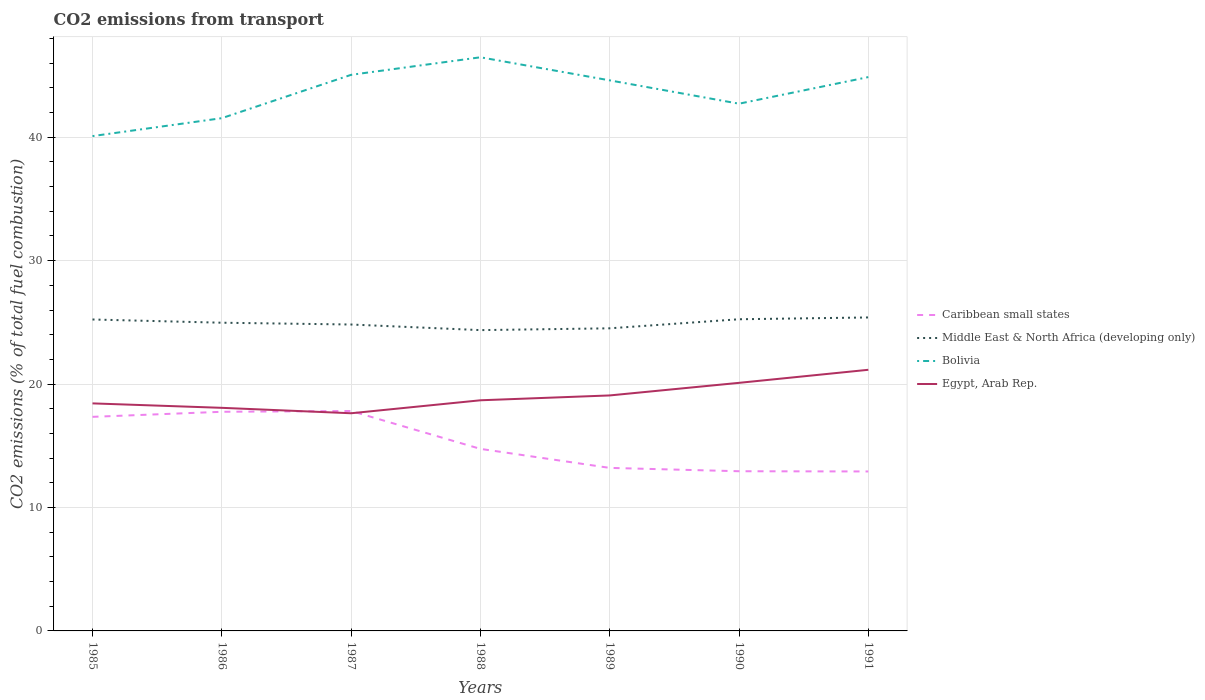How many different coloured lines are there?
Provide a short and direct response. 4. Is the number of lines equal to the number of legend labels?
Keep it short and to the point. Yes. Across all years, what is the maximum total CO2 emitted in Egypt, Arab Rep.?
Offer a very short reply. 17.64. What is the total total CO2 emitted in Caribbean small states in the graph?
Provide a succinct answer. 0.29. What is the difference between the highest and the second highest total CO2 emitted in Egypt, Arab Rep.?
Keep it short and to the point. 3.52. Is the total CO2 emitted in Middle East & North Africa (developing only) strictly greater than the total CO2 emitted in Bolivia over the years?
Provide a succinct answer. Yes. Does the graph contain any zero values?
Ensure brevity in your answer.  No. How many legend labels are there?
Your response must be concise. 4. What is the title of the graph?
Make the answer very short. CO2 emissions from transport. What is the label or title of the Y-axis?
Keep it short and to the point. CO2 emissions (% of total fuel combustion). What is the CO2 emissions (% of total fuel combustion) in Caribbean small states in 1985?
Give a very brief answer. 17.35. What is the CO2 emissions (% of total fuel combustion) in Middle East & North Africa (developing only) in 1985?
Offer a very short reply. 25.23. What is the CO2 emissions (% of total fuel combustion) in Bolivia in 1985?
Ensure brevity in your answer.  40.09. What is the CO2 emissions (% of total fuel combustion) of Egypt, Arab Rep. in 1985?
Your answer should be compact. 18.44. What is the CO2 emissions (% of total fuel combustion) in Caribbean small states in 1986?
Your answer should be compact. 17.76. What is the CO2 emissions (% of total fuel combustion) in Middle East & North Africa (developing only) in 1986?
Your response must be concise. 24.97. What is the CO2 emissions (% of total fuel combustion) of Bolivia in 1986?
Provide a succinct answer. 41.55. What is the CO2 emissions (% of total fuel combustion) of Egypt, Arab Rep. in 1986?
Your answer should be very brief. 18.08. What is the CO2 emissions (% of total fuel combustion) in Caribbean small states in 1987?
Ensure brevity in your answer.  17.82. What is the CO2 emissions (% of total fuel combustion) of Middle East & North Africa (developing only) in 1987?
Make the answer very short. 24.83. What is the CO2 emissions (% of total fuel combustion) in Bolivia in 1987?
Your answer should be very brief. 45.06. What is the CO2 emissions (% of total fuel combustion) of Egypt, Arab Rep. in 1987?
Your answer should be compact. 17.64. What is the CO2 emissions (% of total fuel combustion) in Caribbean small states in 1988?
Ensure brevity in your answer.  14.75. What is the CO2 emissions (% of total fuel combustion) of Middle East & North Africa (developing only) in 1988?
Provide a short and direct response. 24.37. What is the CO2 emissions (% of total fuel combustion) in Bolivia in 1988?
Your response must be concise. 46.48. What is the CO2 emissions (% of total fuel combustion) of Egypt, Arab Rep. in 1988?
Provide a short and direct response. 18.69. What is the CO2 emissions (% of total fuel combustion) in Caribbean small states in 1989?
Make the answer very short. 13.21. What is the CO2 emissions (% of total fuel combustion) of Middle East & North Africa (developing only) in 1989?
Provide a short and direct response. 24.52. What is the CO2 emissions (% of total fuel combustion) in Bolivia in 1989?
Provide a succinct answer. 44.61. What is the CO2 emissions (% of total fuel combustion) of Egypt, Arab Rep. in 1989?
Offer a terse response. 19.08. What is the CO2 emissions (% of total fuel combustion) of Caribbean small states in 1990?
Your answer should be compact. 12.94. What is the CO2 emissions (% of total fuel combustion) of Middle East & North Africa (developing only) in 1990?
Give a very brief answer. 25.25. What is the CO2 emissions (% of total fuel combustion) in Bolivia in 1990?
Provide a short and direct response. 42.72. What is the CO2 emissions (% of total fuel combustion) of Egypt, Arab Rep. in 1990?
Ensure brevity in your answer.  20.1. What is the CO2 emissions (% of total fuel combustion) of Caribbean small states in 1991?
Your answer should be very brief. 12.92. What is the CO2 emissions (% of total fuel combustion) of Middle East & North Africa (developing only) in 1991?
Offer a very short reply. 25.4. What is the CO2 emissions (% of total fuel combustion) in Bolivia in 1991?
Your response must be concise. 44.87. What is the CO2 emissions (% of total fuel combustion) of Egypt, Arab Rep. in 1991?
Offer a very short reply. 21.16. Across all years, what is the maximum CO2 emissions (% of total fuel combustion) of Caribbean small states?
Make the answer very short. 17.82. Across all years, what is the maximum CO2 emissions (% of total fuel combustion) of Middle East & North Africa (developing only)?
Make the answer very short. 25.4. Across all years, what is the maximum CO2 emissions (% of total fuel combustion) in Bolivia?
Provide a short and direct response. 46.48. Across all years, what is the maximum CO2 emissions (% of total fuel combustion) in Egypt, Arab Rep.?
Keep it short and to the point. 21.16. Across all years, what is the minimum CO2 emissions (% of total fuel combustion) of Caribbean small states?
Give a very brief answer. 12.92. Across all years, what is the minimum CO2 emissions (% of total fuel combustion) of Middle East & North Africa (developing only)?
Offer a very short reply. 24.37. Across all years, what is the minimum CO2 emissions (% of total fuel combustion) in Bolivia?
Provide a short and direct response. 40.09. Across all years, what is the minimum CO2 emissions (% of total fuel combustion) in Egypt, Arab Rep.?
Keep it short and to the point. 17.64. What is the total CO2 emissions (% of total fuel combustion) of Caribbean small states in the graph?
Provide a succinct answer. 106.74. What is the total CO2 emissions (% of total fuel combustion) of Middle East & North Africa (developing only) in the graph?
Offer a terse response. 174.58. What is the total CO2 emissions (% of total fuel combustion) in Bolivia in the graph?
Offer a very short reply. 305.38. What is the total CO2 emissions (% of total fuel combustion) in Egypt, Arab Rep. in the graph?
Your answer should be compact. 133.18. What is the difference between the CO2 emissions (% of total fuel combustion) in Caribbean small states in 1985 and that in 1986?
Provide a short and direct response. -0.41. What is the difference between the CO2 emissions (% of total fuel combustion) in Middle East & North Africa (developing only) in 1985 and that in 1986?
Keep it short and to the point. 0.26. What is the difference between the CO2 emissions (% of total fuel combustion) in Bolivia in 1985 and that in 1986?
Ensure brevity in your answer.  -1.45. What is the difference between the CO2 emissions (% of total fuel combustion) of Egypt, Arab Rep. in 1985 and that in 1986?
Give a very brief answer. 0.36. What is the difference between the CO2 emissions (% of total fuel combustion) in Caribbean small states in 1985 and that in 1987?
Provide a short and direct response. -0.47. What is the difference between the CO2 emissions (% of total fuel combustion) in Middle East & North Africa (developing only) in 1985 and that in 1987?
Give a very brief answer. 0.41. What is the difference between the CO2 emissions (% of total fuel combustion) in Bolivia in 1985 and that in 1987?
Provide a succinct answer. -4.96. What is the difference between the CO2 emissions (% of total fuel combustion) in Egypt, Arab Rep. in 1985 and that in 1987?
Provide a succinct answer. 0.8. What is the difference between the CO2 emissions (% of total fuel combustion) of Caribbean small states in 1985 and that in 1988?
Your answer should be very brief. 2.6. What is the difference between the CO2 emissions (% of total fuel combustion) of Middle East & North Africa (developing only) in 1985 and that in 1988?
Your answer should be very brief. 0.86. What is the difference between the CO2 emissions (% of total fuel combustion) in Bolivia in 1985 and that in 1988?
Give a very brief answer. -6.39. What is the difference between the CO2 emissions (% of total fuel combustion) of Egypt, Arab Rep. in 1985 and that in 1988?
Give a very brief answer. -0.25. What is the difference between the CO2 emissions (% of total fuel combustion) in Caribbean small states in 1985 and that in 1989?
Your answer should be very brief. 4.14. What is the difference between the CO2 emissions (% of total fuel combustion) in Middle East & North Africa (developing only) in 1985 and that in 1989?
Your answer should be compact. 0.71. What is the difference between the CO2 emissions (% of total fuel combustion) of Bolivia in 1985 and that in 1989?
Offer a very short reply. -4.52. What is the difference between the CO2 emissions (% of total fuel combustion) of Egypt, Arab Rep. in 1985 and that in 1989?
Keep it short and to the point. -0.64. What is the difference between the CO2 emissions (% of total fuel combustion) in Caribbean small states in 1985 and that in 1990?
Keep it short and to the point. 4.41. What is the difference between the CO2 emissions (% of total fuel combustion) of Middle East & North Africa (developing only) in 1985 and that in 1990?
Keep it short and to the point. -0.02. What is the difference between the CO2 emissions (% of total fuel combustion) of Bolivia in 1985 and that in 1990?
Offer a very short reply. -2.63. What is the difference between the CO2 emissions (% of total fuel combustion) in Egypt, Arab Rep. in 1985 and that in 1990?
Your answer should be compact. -1.66. What is the difference between the CO2 emissions (% of total fuel combustion) of Caribbean small states in 1985 and that in 1991?
Make the answer very short. 4.43. What is the difference between the CO2 emissions (% of total fuel combustion) of Middle East & North Africa (developing only) in 1985 and that in 1991?
Your response must be concise. -0.17. What is the difference between the CO2 emissions (% of total fuel combustion) of Bolivia in 1985 and that in 1991?
Your answer should be very brief. -4.78. What is the difference between the CO2 emissions (% of total fuel combustion) of Egypt, Arab Rep. in 1985 and that in 1991?
Provide a short and direct response. -2.72. What is the difference between the CO2 emissions (% of total fuel combustion) in Caribbean small states in 1986 and that in 1987?
Make the answer very short. -0.06. What is the difference between the CO2 emissions (% of total fuel combustion) of Middle East & North Africa (developing only) in 1986 and that in 1987?
Your response must be concise. 0.15. What is the difference between the CO2 emissions (% of total fuel combustion) in Bolivia in 1986 and that in 1987?
Keep it short and to the point. -3.51. What is the difference between the CO2 emissions (% of total fuel combustion) of Egypt, Arab Rep. in 1986 and that in 1987?
Offer a very short reply. 0.44. What is the difference between the CO2 emissions (% of total fuel combustion) in Caribbean small states in 1986 and that in 1988?
Provide a succinct answer. 3.01. What is the difference between the CO2 emissions (% of total fuel combustion) of Middle East & North Africa (developing only) in 1986 and that in 1988?
Ensure brevity in your answer.  0.6. What is the difference between the CO2 emissions (% of total fuel combustion) of Bolivia in 1986 and that in 1988?
Your response must be concise. -4.93. What is the difference between the CO2 emissions (% of total fuel combustion) in Egypt, Arab Rep. in 1986 and that in 1988?
Your answer should be compact. -0.61. What is the difference between the CO2 emissions (% of total fuel combustion) in Caribbean small states in 1986 and that in 1989?
Make the answer very short. 4.55. What is the difference between the CO2 emissions (% of total fuel combustion) of Middle East & North Africa (developing only) in 1986 and that in 1989?
Make the answer very short. 0.45. What is the difference between the CO2 emissions (% of total fuel combustion) in Bolivia in 1986 and that in 1989?
Provide a short and direct response. -3.06. What is the difference between the CO2 emissions (% of total fuel combustion) of Egypt, Arab Rep. in 1986 and that in 1989?
Ensure brevity in your answer.  -1. What is the difference between the CO2 emissions (% of total fuel combustion) in Caribbean small states in 1986 and that in 1990?
Give a very brief answer. 4.82. What is the difference between the CO2 emissions (% of total fuel combustion) in Middle East & North Africa (developing only) in 1986 and that in 1990?
Your answer should be compact. -0.28. What is the difference between the CO2 emissions (% of total fuel combustion) of Bolivia in 1986 and that in 1990?
Provide a succinct answer. -1.17. What is the difference between the CO2 emissions (% of total fuel combustion) in Egypt, Arab Rep. in 1986 and that in 1990?
Your response must be concise. -2.02. What is the difference between the CO2 emissions (% of total fuel combustion) in Caribbean small states in 1986 and that in 1991?
Provide a succinct answer. 4.84. What is the difference between the CO2 emissions (% of total fuel combustion) of Middle East & North Africa (developing only) in 1986 and that in 1991?
Your answer should be very brief. -0.43. What is the difference between the CO2 emissions (% of total fuel combustion) of Bolivia in 1986 and that in 1991?
Provide a succinct answer. -3.33. What is the difference between the CO2 emissions (% of total fuel combustion) in Egypt, Arab Rep. in 1986 and that in 1991?
Offer a very short reply. -3.08. What is the difference between the CO2 emissions (% of total fuel combustion) of Caribbean small states in 1987 and that in 1988?
Give a very brief answer. 3.07. What is the difference between the CO2 emissions (% of total fuel combustion) of Middle East & North Africa (developing only) in 1987 and that in 1988?
Your answer should be very brief. 0.45. What is the difference between the CO2 emissions (% of total fuel combustion) of Bolivia in 1987 and that in 1988?
Your answer should be very brief. -1.42. What is the difference between the CO2 emissions (% of total fuel combustion) in Egypt, Arab Rep. in 1987 and that in 1988?
Provide a succinct answer. -1.05. What is the difference between the CO2 emissions (% of total fuel combustion) of Caribbean small states in 1987 and that in 1989?
Provide a short and direct response. 4.61. What is the difference between the CO2 emissions (% of total fuel combustion) of Middle East & North Africa (developing only) in 1987 and that in 1989?
Offer a very short reply. 0.31. What is the difference between the CO2 emissions (% of total fuel combustion) in Bolivia in 1987 and that in 1989?
Offer a terse response. 0.45. What is the difference between the CO2 emissions (% of total fuel combustion) in Egypt, Arab Rep. in 1987 and that in 1989?
Offer a very short reply. -1.44. What is the difference between the CO2 emissions (% of total fuel combustion) in Caribbean small states in 1987 and that in 1990?
Offer a terse response. 4.88. What is the difference between the CO2 emissions (% of total fuel combustion) in Middle East & North Africa (developing only) in 1987 and that in 1990?
Provide a succinct answer. -0.43. What is the difference between the CO2 emissions (% of total fuel combustion) of Bolivia in 1987 and that in 1990?
Offer a terse response. 2.34. What is the difference between the CO2 emissions (% of total fuel combustion) of Egypt, Arab Rep. in 1987 and that in 1990?
Offer a very short reply. -2.46. What is the difference between the CO2 emissions (% of total fuel combustion) in Caribbean small states in 1987 and that in 1991?
Provide a succinct answer. 4.9. What is the difference between the CO2 emissions (% of total fuel combustion) of Middle East & North Africa (developing only) in 1987 and that in 1991?
Keep it short and to the point. -0.57. What is the difference between the CO2 emissions (% of total fuel combustion) of Bolivia in 1987 and that in 1991?
Your answer should be compact. 0.18. What is the difference between the CO2 emissions (% of total fuel combustion) in Egypt, Arab Rep. in 1987 and that in 1991?
Provide a short and direct response. -3.52. What is the difference between the CO2 emissions (% of total fuel combustion) in Caribbean small states in 1988 and that in 1989?
Your answer should be very brief. 1.54. What is the difference between the CO2 emissions (% of total fuel combustion) in Middle East & North Africa (developing only) in 1988 and that in 1989?
Provide a succinct answer. -0.15. What is the difference between the CO2 emissions (% of total fuel combustion) in Bolivia in 1988 and that in 1989?
Offer a terse response. 1.87. What is the difference between the CO2 emissions (% of total fuel combustion) of Egypt, Arab Rep. in 1988 and that in 1989?
Ensure brevity in your answer.  -0.39. What is the difference between the CO2 emissions (% of total fuel combustion) in Caribbean small states in 1988 and that in 1990?
Offer a terse response. 1.81. What is the difference between the CO2 emissions (% of total fuel combustion) of Middle East & North Africa (developing only) in 1988 and that in 1990?
Offer a very short reply. -0.88. What is the difference between the CO2 emissions (% of total fuel combustion) of Bolivia in 1988 and that in 1990?
Keep it short and to the point. 3.76. What is the difference between the CO2 emissions (% of total fuel combustion) in Egypt, Arab Rep. in 1988 and that in 1990?
Your answer should be compact. -1.41. What is the difference between the CO2 emissions (% of total fuel combustion) of Caribbean small states in 1988 and that in 1991?
Your response must be concise. 1.83. What is the difference between the CO2 emissions (% of total fuel combustion) of Middle East & North Africa (developing only) in 1988 and that in 1991?
Provide a short and direct response. -1.03. What is the difference between the CO2 emissions (% of total fuel combustion) of Bolivia in 1988 and that in 1991?
Give a very brief answer. 1.6. What is the difference between the CO2 emissions (% of total fuel combustion) in Egypt, Arab Rep. in 1988 and that in 1991?
Ensure brevity in your answer.  -2.47. What is the difference between the CO2 emissions (% of total fuel combustion) of Caribbean small states in 1989 and that in 1990?
Your answer should be compact. 0.27. What is the difference between the CO2 emissions (% of total fuel combustion) in Middle East & North Africa (developing only) in 1989 and that in 1990?
Give a very brief answer. -0.73. What is the difference between the CO2 emissions (% of total fuel combustion) of Bolivia in 1989 and that in 1990?
Give a very brief answer. 1.89. What is the difference between the CO2 emissions (% of total fuel combustion) in Egypt, Arab Rep. in 1989 and that in 1990?
Make the answer very short. -1.02. What is the difference between the CO2 emissions (% of total fuel combustion) of Caribbean small states in 1989 and that in 1991?
Your response must be concise. 0.29. What is the difference between the CO2 emissions (% of total fuel combustion) of Middle East & North Africa (developing only) in 1989 and that in 1991?
Provide a succinct answer. -0.88. What is the difference between the CO2 emissions (% of total fuel combustion) in Bolivia in 1989 and that in 1991?
Provide a short and direct response. -0.27. What is the difference between the CO2 emissions (% of total fuel combustion) of Egypt, Arab Rep. in 1989 and that in 1991?
Make the answer very short. -2.08. What is the difference between the CO2 emissions (% of total fuel combustion) in Caribbean small states in 1990 and that in 1991?
Offer a terse response. 0.02. What is the difference between the CO2 emissions (% of total fuel combustion) of Middle East & North Africa (developing only) in 1990 and that in 1991?
Provide a short and direct response. -0.15. What is the difference between the CO2 emissions (% of total fuel combustion) in Bolivia in 1990 and that in 1991?
Provide a succinct answer. -2.16. What is the difference between the CO2 emissions (% of total fuel combustion) of Egypt, Arab Rep. in 1990 and that in 1991?
Offer a terse response. -1.06. What is the difference between the CO2 emissions (% of total fuel combustion) of Caribbean small states in 1985 and the CO2 emissions (% of total fuel combustion) of Middle East & North Africa (developing only) in 1986?
Offer a very short reply. -7.63. What is the difference between the CO2 emissions (% of total fuel combustion) in Caribbean small states in 1985 and the CO2 emissions (% of total fuel combustion) in Bolivia in 1986?
Provide a short and direct response. -24.2. What is the difference between the CO2 emissions (% of total fuel combustion) in Caribbean small states in 1985 and the CO2 emissions (% of total fuel combustion) in Egypt, Arab Rep. in 1986?
Ensure brevity in your answer.  -0.73. What is the difference between the CO2 emissions (% of total fuel combustion) in Middle East & North Africa (developing only) in 1985 and the CO2 emissions (% of total fuel combustion) in Bolivia in 1986?
Your answer should be very brief. -16.31. What is the difference between the CO2 emissions (% of total fuel combustion) in Middle East & North Africa (developing only) in 1985 and the CO2 emissions (% of total fuel combustion) in Egypt, Arab Rep. in 1986?
Your response must be concise. 7.16. What is the difference between the CO2 emissions (% of total fuel combustion) in Bolivia in 1985 and the CO2 emissions (% of total fuel combustion) in Egypt, Arab Rep. in 1986?
Provide a succinct answer. 22.02. What is the difference between the CO2 emissions (% of total fuel combustion) of Caribbean small states in 1985 and the CO2 emissions (% of total fuel combustion) of Middle East & North Africa (developing only) in 1987?
Ensure brevity in your answer.  -7.48. What is the difference between the CO2 emissions (% of total fuel combustion) of Caribbean small states in 1985 and the CO2 emissions (% of total fuel combustion) of Bolivia in 1987?
Your response must be concise. -27.71. What is the difference between the CO2 emissions (% of total fuel combustion) of Caribbean small states in 1985 and the CO2 emissions (% of total fuel combustion) of Egypt, Arab Rep. in 1987?
Offer a very short reply. -0.29. What is the difference between the CO2 emissions (% of total fuel combustion) in Middle East & North Africa (developing only) in 1985 and the CO2 emissions (% of total fuel combustion) in Bolivia in 1987?
Make the answer very short. -19.82. What is the difference between the CO2 emissions (% of total fuel combustion) of Middle East & North Africa (developing only) in 1985 and the CO2 emissions (% of total fuel combustion) of Egypt, Arab Rep. in 1987?
Your response must be concise. 7.6. What is the difference between the CO2 emissions (% of total fuel combustion) of Bolivia in 1985 and the CO2 emissions (% of total fuel combustion) of Egypt, Arab Rep. in 1987?
Keep it short and to the point. 22.46. What is the difference between the CO2 emissions (% of total fuel combustion) of Caribbean small states in 1985 and the CO2 emissions (% of total fuel combustion) of Middle East & North Africa (developing only) in 1988?
Offer a very short reply. -7.03. What is the difference between the CO2 emissions (% of total fuel combustion) of Caribbean small states in 1985 and the CO2 emissions (% of total fuel combustion) of Bolivia in 1988?
Your answer should be very brief. -29.13. What is the difference between the CO2 emissions (% of total fuel combustion) of Caribbean small states in 1985 and the CO2 emissions (% of total fuel combustion) of Egypt, Arab Rep. in 1988?
Your response must be concise. -1.34. What is the difference between the CO2 emissions (% of total fuel combustion) of Middle East & North Africa (developing only) in 1985 and the CO2 emissions (% of total fuel combustion) of Bolivia in 1988?
Provide a succinct answer. -21.25. What is the difference between the CO2 emissions (% of total fuel combustion) in Middle East & North Africa (developing only) in 1985 and the CO2 emissions (% of total fuel combustion) in Egypt, Arab Rep. in 1988?
Offer a very short reply. 6.55. What is the difference between the CO2 emissions (% of total fuel combustion) of Bolivia in 1985 and the CO2 emissions (% of total fuel combustion) of Egypt, Arab Rep. in 1988?
Provide a succinct answer. 21.41. What is the difference between the CO2 emissions (% of total fuel combustion) of Caribbean small states in 1985 and the CO2 emissions (% of total fuel combustion) of Middle East & North Africa (developing only) in 1989?
Make the answer very short. -7.17. What is the difference between the CO2 emissions (% of total fuel combustion) in Caribbean small states in 1985 and the CO2 emissions (% of total fuel combustion) in Bolivia in 1989?
Your answer should be very brief. -27.26. What is the difference between the CO2 emissions (% of total fuel combustion) in Caribbean small states in 1985 and the CO2 emissions (% of total fuel combustion) in Egypt, Arab Rep. in 1989?
Offer a terse response. -1.73. What is the difference between the CO2 emissions (% of total fuel combustion) of Middle East & North Africa (developing only) in 1985 and the CO2 emissions (% of total fuel combustion) of Bolivia in 1989?
Give a very brief answer. -19.38. What is the difference between the CO2 emissions (% of total fuel combustion) in Middle East & North Africa (developing only) in 1985 and the CO2 emissions (% of total fuel combustion) in Egypt, Arab Rep. in 1989?
Your answer should be compact. 6.15. What is the difference between the CO2 emissions (% of total fuel combustion) of Bolivia in 1985 and the CO2 emissions (% of total fuel combustion) of Egypt, Arab Rep. in 1989?
Offer a very short reply. 21.01. What is the difference between the CO2 emissions (% of total fuel combustion) of Caribbean small states in 1985 and the CO2 emissions (% of total fuel combustion) of Middle East & North Africa (developing only) in 1990?
Your answer should be compact. -7.91. What is the difference between the CO2 emissions (% of total fuel combustion) in Caribbean small states in 1985 and the CO2 emissions (% of total fuel combustion) in Bolivia in 1990?
Keep it short and to the point. -25.37. What is the difference between the CO2 emissions (% of total fuel combustion) of Caribbean small states in 1985 and the CO2 emissions (% of total fuel combustion) of Egypt, Arab Rep. in 1990?
Your answer should be very brief. -2.76. What is the difference between the CO2 emissions (% of total fuel combustion) of Middle East & North Africa (developing only) in 1985 and the CO2 emissions (% of total fuel combustion) of Bolivia in 1990?
Keep it short and to the point. -17.48. What is the difference between the CO2 emissions (% of total fuel combustion) of Middle East & North Africa (developing only) in 1985 and the CO2 emissions (% of total fuel combustion) of Egypt, Arab Rep. in 1990?
Provide a short and direct response. 5.13. What is the difference between the CO2 emissions (% of total fuel combustion) of Bolivia in 1985 and the CO2 emissions (% of total fuel combustion) of Egypt, Arab Rep. in 1990?
Ensure brevity in your answer.  19.99. What is the difference between the CO2 emissions (% of total fuel combustion) in Caribbean small states in 1985 and the CO2 emissions (% of total fuel combustion) in Middle East & North Africa (developing only) in 1991?
Offer a very short reply. -8.05. What is the difference between the CO2 emissions (% of total fuel combustion) in Caribbean small states in 1985 and the CO2 emissions (% of total fuel combustion) in Bolivia in 1991?
Your response must be concise. -27.53. What is the difference between the CO2 emissions (% of total fuel combustion) in Caribbean small states in 1985 and the CO2 emissions (% of total fuel combustion) in Egypt, Arab Rep. in 1991?
Give a very brief answer. -3.81. What is the difference between the CO2 emissions (% of total fuel combustion) of Middle East & North Africa (developing only) in 1985 and the CO2 emissions (% of total fuel combustion) of Bolivia in 1991?
Your response must be concise. -19.64. What is the difference between the CO2 emissions (% of total fuel combustion) of Middle East & North Africa (developing only) in 1985 and the CO2 emissions (% of total fuel combustion) of Egypt, Arab Rep. in 1991?
Provide a short and direct response. 4.08. What is the difference between the CO2 emissions (% of total fuel combustion) in Bolivia in 1985 and the CO2 emissions (% of total fuel combustion) in Egypt, Arab Rep. in 1991?
Your answer should be compact. 18.93. What is the difference between the CO2 emissions (% of total fuel combustion) of Caribbean small states in 1986 and the CO2 emissions (% of total fuel combustion) of Middle East & North Africa (developing only) in 1987?
Offer a very short reply. -7.07. What is the difference between the CO2 emissions (% of total fuel combustion) in Caribbean small states in 1986 and the CO2 emissions (% of total fuel combustion) in Bolivia in 1987?
Keep it short and to the point. -27.3. What is the difference between the CO2 emissions (% of total fuel combustion) in Caribbean small states in 1986 and the CO2 emissions (% of total fuel combustion) in Egypt, Arab Rep. in 1987?
Offer a very short reply. 0.12. What is the difference between the CO2 emissions (% of total fuel combustion) in Middle East & North Africa (developing only) in 1986 and the CO2 emissions (% of total fuel combustion) in Bolivia in 1987?
Your response must be concise. -20.09. What is the difference between the CO2 emissions (% of total fuel combustion) in Middle East & North Africa (developing only) in 1986 and the CO2 emissions (% of total fuel combustion) in Egypt, Arab Rep. in 1987?
Make the answer very short. 7.34. What is the difference between the CO2 emissions (% of total fuel combustion) of Bolivia in 1986 and the CO2 emissions (% of total fuel combustion) of Egypt, Arab Rep. in 1987?
Keep it short and to the point. 23.91. What is the difference between the CO2 emissions (% of total fuel combustion) of Caribbean small states in 1986 and the CO2 emissions (% of total fuel combustion) of Middle East & North Africa (developing only) in 1988?
Your answer should be very brief. -6.62. What is the difference between the CO2 emissions (% of total fuel combustion) of Caribbean small states in 1986 and the CO2 emissions (% of total fuel combustion) of Bolivia in 1988?
Make the answer very short. -28.72. What is the difference between the CO2 emissions (% of total fuel combustion) in Caribbean small states in 1986 and the CO2 emissions (% of total fuel combustion) in Egypt, Arab Rep. in 1988?
Your answer should be compact. -0.93. What is the difference between the CO2 emissions (% of total fuel combustion) in Middle East & North Africa (developing only) in 1986 and the CO2 emissions (% of total fuel combustion) in Bolivia in 1988?
Provide a short and direct response. -21.51. What is the difference between the CO2 emissions (% of total fuel combustion) in Middle East & North Africa (developing only) in 1986 and the CO2 emissions (% of total fuel combustion) in Egypt, Arab Rep. in 1988?
Provide a succinct answer. 6.29. What is the difference between the CO2 emissions (% of total fuel combustion) of Bolivia in 1986 and the CO2 emissions (% of total fuel combustion) of Egypt, Arab Rep. in 1988?
Keep it short and to the point. 22.86. What is the difference between the CO2 emissions (% of total fuel combustion) in Caribbean small states in 1986 and the CO2 emissions (% of total fuel combustion) in Middle East & North Africa (developing only) in 1989?
Give a very brief answer. -6.76. What is the difference between the CO2 emissions (% of total fuel combustion) of Caribbean small states in 1986 and the CO2 emissions (% of total fuel combustion) of Bolivia in 1989?
Offer a very short reply. -26.85. What is the difference between the CO2 emissions (% of total fuel combustion) of Caribbean small states in 1986 and the CO2 emissions (% of total fuel combustion) of Egypt, Arab Rep. in 1989?
Make the answer very short. -1.32. What is the difference between the CO2 emissions (% of total fuel combustion) in Middle East & North Africa (developing only) in 1986 and the CO2 emissions (% of total fuel combustion) in Bolivia in 1989?
Keep it short and to the point. -19.64. What is the difference between the CO2 emissions (% of total fuel combustion) in Middle East & North Africa (developing only) in 1986 and the CO2 emissions (% of total fuel combustion) in Egypt, Arab Rep. in 1989?
Ensure brevity in your answer.  5.89. What is the difference between the CO2 emissions (% of total fuel combustion) of Bolivia in 1986 and the CO2 emissions (% of total fuel combustion) of Egypt, Arab Rep. in 1989?
Make the answer very short. 22.47. What is the difference between the CO2 emissions (% of total fuel combustion) of Caribbean small states in 1986 and the CO2 emissions (% of total fuel combustion) of Middle East & North Africa (developing only) in 1990?
Your answer should be very brief. -7.5. What is the difference between the CO2 emissions (% of total fuel combustion) in Caribbean small states in 1986 and the CO2 emissions (% of total fuel combustion) in Bolivia in 1990?
Your answer should be very brief. -24.96. What is the difference between the CO2 emissions (% of total fuel combustion) of Caribbean small states in 1986 and the CO2 emissions (% of total fuel combustion) of Egypt, Arab Rep. in 1990?
Keep it short and to the point. -2.34. What is the difference between the CO2 emissions (% of total fuel combustion) in Middle East & North Africa (developing only) in 1986 and the CO2 emissions (% of total fuel combustion) in Bolivia in 1990?
Ensure brevity in your answer.  -17.75. What is the difference between the CO2 emissions (% of total fuel combustion) in Middle East & North Africa (developing only) in 1986 and the CO2 emissions (% of total fuel combustion) in Egypt, Arab Rep. in 1990?
Give a very brief answer. 4.87. What is the difference between the CO2 emissions (% of total fuel combustion) in Bolivia in 1986 and the CO2 emissions (% of total fuel combustion) in Egypt, Arab Rep. in 1990?
Make the answer very short. 21.45. What is the difference between the CO2 emissions (% of total fuel combustion) of Caribbean small states in 1986 and the CO2 emissions (% of total fuel combustion) of Middle East & North Africa (developing only) in 1991?
Your answer should be compact. -7.64. What is the difference between the CO2 emissions (% of total fuel combustion) in Caribbean small states in 1986 and the CO2 emissions (% of total fuel combustion) in Bolivia in 1991?
Your answer should be very brief. -27.12. What is the difference between the CO2 emissions (% of total fuel combustion) of Caribbean small states in 1986 and the CO2 emissions (% of total fuel combustion) of Egypt, Arab Rep. in 1991?
Offer a very short reply. -3.4. What is the difference between the CO2 emissions (% of total fuel combustion) in Middle East & North Africa (developing only) in 1986 and the CO2 emissions (% of total fuel combustion) in Bolivia in 1991?
Provide a succinct answer. -19.9. What is the difference between the CO2 emissions (% of total fuel combustion) in Middle East & North Africa (developing only) in 1986 and the CO2 emissions (% of total fuel combustion) in Egypt, Arab Rep. in 1991?
Give a very brief answer. 3.81. What is the difference between the CO2 emissions (% of total fuel combustion) in Bolivia in 1986 and the CO2 emissions (% of total fuel combustion) in Egypt, Arab Rep. in 1991?
Give a very brief answer. 20.39. What is the difference between the CO2 emissions (% of total fuel combustion) in Caribbean small states in 1987 and the CO2 emissions (% of total fuel combustion) in Middle East & North Africa (developing only) in 1988?
Keep it short and to the point. -6.55. What is the difference between the CO2 emissions (% of total fuel combustion) in Caribbean small states in 1987 and the CO2 emissions (% of total fuel combustion) in Bolivia in 1988?
Your response must be concise. -28.66. What is the difference between the CO2 emissions (% of total fuel combustion) in Caribbean small states in 1987 and the CO2 emissions (% of total fuel combustion) in Egypt, Arab Rep. in 1988?
Your answer should be very brief. -0.87. What is the difference between the CO2 emissions (% of total fuel combustion) of Middle East & North Africa (developing only) in 1987 and the CO2 emissions (% of total fuel combustion) of Bolivia in 1988?
Your answer should be compact. -21.65. What is the difference between the CO2 emissions (% of total fuel combustion) in Middle East & North Africa (developing only) in 1987 and the CO2 emissions (% of total fuel combustion) in Egypt, Arab Rep. in 1988?
Provide a short and direct response. 6.14. What is the difference between the CO2 emissions (% of total fuel combustion) of Bolivia in 1987 and the CO2 emissions (% of total fuel combustion) of Egypt, Arab Rep. in 1988?
Offer a terse response. 26.37. What is the difference between the CO2 emissions (% of total fuel combustion) in Caribbean small states in 1987 and the CO2 emissions (% of total fuel combustion) in Middle East & North Africa (developing only) in 1989?
Your answer should be very brief. -6.7. What is the difference between the CO2 emissions (% of total fuel combustion) of Caribbean small states in 1987 and the CO2 emissions (% of total fuel combustion) of Bolivia in 1989?
Offer a very short reply. -26.79. What is the difference between the CO2 emissions (% of total fuel combustion) of Caribbean small states in 1987 and the CO2 emissions (% of total fuel combustion) of Egypt, Arab Rep. in 1989?
Give a very brief answer. -1.26. What is the difference between the CO2 emissions (% of total fuel combustion) of Middle East & North Africa (developing only) in 1987 and the CO2 emissions (% of total fuel combustion) of Bolivia in 1989?
Offer a terse response. -19.78. What is the difference between the CO2 emissions (% of total fuel combustion) in Middle East & North Africa (developing only) in 1987 and the CO2 emissions (% of total fuel combustion) in Egypt, Arab Rep. in 1989?
Keep it short and to the point. 5.75. What is the difference between the CO2 emissions (% of total fuel combustion) in Bolivia in 1987 and the CO2 emissions (% of total fuel combustion) in Egypt, Arab Rep. in 1989?
Give a very brief answer. 25.98. What is the difference between the CO2 emissions (% of total fuel combustion) in Caribbean small states in 1987 and the CO2 emissions (% of total fuel combustion) in Middle East & North Africa (developing only) in 1990?
Your response must be concise. -7.43. What is the difference between the CO2 emissions (% of total fuel combustion) of Caribbean small states in 1987 and the CO2 emissions (% of total fuel combustion) of Bolivia in 1990?
Your answer should be very brief. -24.9. What is the difference between the CO2 emissions (% of total fuel combustion) in Caribbean small states in 1987 and the CO2 emissions (% of total fuel combustion) in Egypt, Arab Rep. in 1990?
Provide a succinct answer. -2.28. What is the difference between the CO2 emissions (% of total fuel combustion) in Middle East & North Africa (developing only) in 1987 and the CO2 emissions (% of total fuel combustion) in Bolivia in 1990?
Make the answer very short. -17.89. What is the difference between the CO2 emissions (% of total fuel combustion) of Middle East & North Africa (developing only) in 1987 and the CO2 emissions (% of total fuel combustion) of Egypt, Arab Rep. in 1990?
Make the answer very short. 4.73. What is the difference between the CO2 emissions (% of total fuel combustion) of Bolivia in 1987 and the CO2 emissions (% of total fuel combustion) of Egypt, Arab Rep. in 1990?
Offer a terse response. 24.96. What is the difference between the CO2 emissions (% of total fuel combustion) of Caribbean small states in 1987 and the CO2 emissions (% of total fuel combustion) of Middle East & North Africa (developing only) in 1991?
Offer a terse response. -7.58. What is the difference between the CO2 emissions (% of total fuel combustion) of Caribbean small states in 1987 and the CO2 emissions (% of total fuel combustion) of Bolivia in 1991?
Your answer should be compact. -27.06. What is the difference between the CO2 emissions (% of total fuel combustion) of Caribbean small states in 1987 and the CO2 emissions (% of total fuel combustion) of Egypt, Arab Rep. in 1991?
Your answer should be very brief. -3.34. What is the difference between the CO2 emissions (% of total fuel combustion) of Middle East & North Africa (developing only) in 1987 and the CO2 emissions (% of total fuel combustion) of Bolivia in 1991?
Your answer should be compact. -20.05. What is the difference between the CO2 emissions (% of total fuel combustion) in Middle East & North Africa (developing only) in 1987 and the CO2 emissions (% of total fuel combustion) in Egypt, Arab Rep. in 1991?
Your answer should be very brief. 3.67. What is the difference between the CO2 emissions (% of total fuel combustion) in Bolivia in 1987 and the CO2 emissions (% of total fuel combustion) in Egypt, Arab Rep. in 1991?
Make the answer very short. 23.9. What is the difference between the CO2 emissions (% of total fuel combustion) in Caribbean small states in 1988 and the CO2 emissions (% of total fuel combustion) in Middle East & North Africa (developing only) in 1989?
Ensure brevity in your answer.  -9.77. What is the difference between the CO2 emissions (% of total fuel combustion) in Caribbean small states in 1988 and the CO2 emissions (% of total fuel combustion) in Bolivia in 1989?
Your answer should be compact. -29.86. What is the difference between the CO2 emissions (% of total fuel combustion) of Caribbean small states in 1988 and the CO2 emissions (% of total fuel combustion) of Egypt, Arab Rep. in 1989?
Give a very brief answer. -4.33. What is the difference between the CO2 emissions (% of total fuel combustion) of Middle East & North Africa (developing only) in 1988 and the CO2 emissions (% of total fuel combustion) of Bolivia in 1989?
Offer a terse response. -20.24. What is the difference between the CO2 emissions (% of total fuel combustion) in Middle East & North Africa (developing only) in 1988 and the CO2 emissions (% of total fuel combustion) in Egypt, Arab Rep. in 1989?
Keep it short and to the point. 5.29. What is the difference between the CO2 emissions (% of total fuel combustion) in Bolivia in 1988 and the CO2 emissions (% of total fuel combustion) in Egypt, Arab Rep. in 1989?
Your answer should be compact. 27.4. What is the difference between the CO2 emissions (% of total fuel combustion) of Caribbean small states in 1988 and the CO2 emissions (% of total fuel combustion) of Middle East & North Africa (developing only) in 1990?
Your answer should be very brief. -10.5. What is the difference between the CO2 emissions (% of total fuel combustion) in Caribbean small states in 1988 and the CO2 emissions (% of total fuel combustion) in Bolivia in 1990?
Provide a short and direct response. -27.97. What is the difference between the CO2 emissions (% of total fuel combustion) of Caribbean small states in 1988 and the CO2 emissions (% of total fuel combustion) of Egypt, Arab Rep. in 1990?
Ensure brevity in your answer.  -5.35. What is the difference between the CO2 emissions (% of total fuel combustion) of Middle East & North Africa (developing only) in 1988 and the CO2 emissions (% of total fuel combustion) of Bolivia in 1990?
Ensure brevity in your answer.  -18.35. What is the difference between the CO2 emissions (% of total fuel combustion) in Middle East & North Africa (developing only) in 1988 and the CO2 emissions (% of total fuel combustion) in Egypt, Arab Rep. in 1990?
Give a very brief answer. 4.27. What is the difference between the CO2 emissions (% of total fuel combustion) of Bolivia in 1988 and the CO2 emissions (% of total fuel combustion) of Egypt, Arab Rep. in 1990?
Ensure brevity in your answer.  26.38. What is the difference between the CO2 emissions (% of total fuel combustion) in Caribbean small states in 1988 and the CO2 emissions (% of total fuel combustion) in Middle East & North Africa (developing only) in 1991?
Your answer should be very brief. -10.65. What is the difference between the CO2 emissions (% of total fuel combustion) of Caribbean small states in 1988 and the CO2 emissions (% of total fuel combustion) of Bolivia in 1991?
Make the answer very short. -30.12. What is the difference between the CO2 emissions (% of total fuel combustion) in Caribbean small states in 1988 and the CO2 emissions (% of total fuel combustion) in Egypt, Arab Rep. in 1991?
Your answer should be very brief. -6.41. What is the difference between the CO2 emissions (% of total fuel combustion) of Middle East & North Africa (developing only) in 1988 and the CO2 emissions (% of total fuel combustion) of Bolivia in 1991?
Provide a succinct answer. -20.5. What is the difference between the CO2 emissions (% of total fuel combustion) in Middle East & North Africa (developing only) in 1988 and the CO2 emissions (% of total fuel combustion) in Egypt, Arab Rep. in 1991?
Make the answer very short. 3.21. What is the difference between the CO2 emissions (% of total fuel combustion) of Bolivia in 1988 and the CO2 emissions (% of total fuel combustion) of Egypt, Arab Rep. in 1991?
Provide a short and direct response. 25.32. What is the difference between the CO2 emissions (% of total fuel combustion) of Caribbean small states in 1989 and the CO2 emissions (% of total fuel combustion) of Middle East & North Africa (developing only) in 1990?
Offer a very short reply. -12.04. What is the difference between the CO2 emissions (% of total fuel combustion) in Caribbean small states in 1989 and the CO2 emissions (% of total fuel combustion) in Bolivia in 1990?
Your response must be concise. -29.51. What is the difference between the CO2 emissions (% of total fuel combustion) in Caribbean small states in 1989 and the CO2 emissions (% of total fuel combustion) in Egypt, Arab Rep. in 1990?
Your answer should be compact. -6.89. What is the difference between the CO2 emissions (% of total fuel combustion) in Middle East & North Africa (developing only) in 1989 and the CO2 emissions (% of total fuel combustion) in Bolivia in 1990?
Your answer should be very brief. -18.2. What is the difference between the CO2 emissions (% of total fuel combustion) of Middle East & North Africa (developing only) in 1989 and the CO2 emissions (% of total fuel combustion) of Egypt, Arab Rep. in 1990?
Provide a short and direct response. 4.42. What is the difference between the CO2 emissions (% of total fuel combustion) of Bolivia in 1989 and the CO2 emissions (% of total fuel combustion) of Egypt, Arab Rep. in 1990?
Your response must be concise. 24.51. What is the difference between the CO2 emissions (% of total fuel combustion) in Caribbean small states in 1989 and the CO2 emissions (% of total fuel combustion) in Middle East & North Africa (developing only) in 1991?
Ensure brevity in your answer.  -12.19. What is the difference between the CO2 emissions (% of total fuel combustion) in Caribbean small states in 1989 and the CO2 emissions (% of total fuel combustion) in Bolivia in 1991?
Your response must be concise. -31.66. What is the difference between the CO2 emissions (% of total fuel combustion) of Caribbean small states in 1989 and the CO2 emissions (% of total fuel combustion) of Egypt, Arab Rep. in 1991?
Offer a very short reply. -7.95. What is the difference between the CO2 emissions (% of total fuel combustion) in Middle East & North Africa (developing only) in 1989 and the CO2 emissions (% of total fuel combustion) in Bolivia in 1991?
Offer a terse response. -20.36. What is the difference between the CO2 emissions (% of total fuel combustion) of Middle East & North Africa (developing only) in 1989 and the CO2 emissions (% of total fuel combustion) of Egypt, Arab Rep. in 1991?
Provide a short and direct response. 3.36. What is the difference between the CO2 emissions (% of total fuel combustion) in Bolivia in 1989 and the CO2 emissions (% of total fuel combustion) in Egypt, Arab Rep. in 1991?
Offer a very short reply. 23.45. What is the difference between the CO2 emissions (% of total fuel combustion) of Caribbean small states in 1990 and the CO2 emissions (% of total fuel combustion) of Middle East & North Africa (developing only) in 1991?
Provide a succinct answer. -12.46. What is the difference between the CO2 emissions (% of total fuel combustion) of Caribbean small states in 1990 and the CO2 emissions (% of total fuel combustion) of Bolivia in 1991?
Your answer should be compact. -31.94. What is the difference between the CO2 emissions (% of total fuel combustion) in Caribbean small states in 1990 and the CO2 emissions (% of total fuel combustion) in Egypt, Arab Rep. in 1991?
Keep it short and to the point. -8.22. What is the difference between the CO2 emissions (% of total fuel combustion) of Middle East & North Africa (developing only) in 1990 and the CO2 emissions (% of total fuel combustion) of Bolivia in 1991?
Offer a very short reply. -19.62. What is the difference between the CO2 emissions (% of total fuel combustion) of Middle East & North Africa (developing only) in 1990 and the CO2 emissions (% of total fuel combustion) of Egypt, Arab Rep. in 1991?
Make the answer very short. 4.09. What is the difference between the CO2 emissions (% of total fuel combustion) of Bolivia in 1990 and the CO2 emissions (% of total fuel combustion) of Egypt, Arab Rep. in 1991?
Ensure brevity in your answer.  21.56. What is the average CO2 emissions (% of total fuel combustion) in Caribbean small states per year?
Make the answer very short. 15.25. What is the average CO2 emissions (% of total fuel combustion) of Middle East & North Africa (developing only) per year?
Provide a short and direct response. 24.94. What is the average CO2 emissions (% of total fuel combustion) of Bolivia per year?
Keep it short and to the point. 43.63. What is the average CO2 emissions (% of total fuel combustion) of Egypt, Arab Rep. per year?
Provide a succinct answer. 19.03. In the year 1985, what is the difference between the CO2 emissions (% of total fuel combustion) of Caribbean small states and CO2 emissions (% of total fuel combustion) of Middle East & North Africa (developing only)?
Your answer should be very brief. -7.89. In the year 1985, what is the difference between the CO2 emissions (% of total fuel combustion) of Caribbean small states and CO2 emissions (% of total fuel combustion) of Bolivia?
Your answer should be very brief. -22.75. In the year 1985, what is the difference between the CO2 emissions (% of total fuel combustion) of Caribbean small states and CO2 emissions (% of total fuel combustion) of Egypt, Arab Rep.?
Provide a short and direct response. -1.09. In the year 1985, what is the difference between the CO2 emissions (% of total fuel combustion) of Middle East & North Africa (developing only) and CO2 emissions (% of total fuel combustion) of Bolivia?
Give a very brief answer. -14.86. In the year 1985, what is the difference between the CO2 emissions (% of total fuel combustion) in Middle East & North Africa (developing only) and CO2 emissions (% of total fuel combustion) in Egypt, Arab Rep.?
Ensure brevity in your answer.  6.8. In the year 1985, what is the difference between the CO2 emissions (% of total fuel combustion) in Bolivia and CO2 emissions (% of total fuel combustion) in Egypt, Arab Rep.?
Provide a short and direct response. 21.66. In the year 1986, what is the difference between the CO2 emissions (% of total fuel combustion) in Caribbean small states and CO2 emissions (% of total fuel combustion) in Middle East & North Africa (developing only)?
Provide a short and direct response. -7.22. In the year 1986, what is the difference between the CO2 emissions (% of total fuel combustion) of Caribbean small states and CO2 emissions (% of total fuel combustion) of Bolivia?
Keep it short and to the point. -23.79. In the year 1986, what is the difference between the CO2 emissions (% of total fuel combustion) of Caribbean small states and CO2 emissions (% of total fuel combustion) of Egypt, Arab Rep.?
Provide a succinct answer. -0.32. In the year 1986, what is the difference between the CO2 emissions (% of total fuel combustion) in Middle East & North Africa (developing only) and CO2 emissions (% of total fuel combustion) in Bolivia?
Offer a terse response. -16.57. In the year 1986, what is the difference between the CO2 emissions (% of total fuel combustion) in Middle East & North Africa (developing only) and CO2 emissions (% of total fuel combustion) in Egypt, Arab Rep.?
Give a very brief answer. 6.9. In the year 1986, what is the difference between the CO2 emissions (% of total fuel combustion) of Bolivia and CO2 emissions (% of total fuel combustion) of Egypt, Arab Rep.?
Ensure brevity in your answer.  23.47. In the year 1987, what is the difference between the CO2 emissions (% of total fuel combustion) of Caribbean small states and CO2 emissions (% of total fuel combustion) of Middle East & North Africa (developing only)?
Your response must be concise. -7.01. In the year 1987, what is the difference between the CO2 emissions (% of total fuel combustion) in Caribbean small states and CO2 emissions (% of total fuel combustion) in Bolivia?
Offer a terse response. -27.24. In the year 1987, what is the difference between the CO2 emissions (% of total fuel combustion) in Caribbean small states and CO2 emissions (% of total fuel combustion) in Egypt, Arab Rep.?
Ensure brevity in your answer.  0.18. In the year 1987, what is the difference between the CO2 emissions (% of total fuel combustion) in Middle East & North Africa (developing only) and CO2 emissions (% of total fuel combustion) in Bolivia?
Make the answer very short. -20.23. In the year 1987, what is the difference between the CO2 emissions (% of total fuel combustion) in Middle East & North Africa (developing only) and CO2 emissions (% of total fuel combustion) in Egypt, Arab Rep.?
Your answer should be compact. 7.19. In the year 1987, what is the difference between the CO2 emissions (% of total fuel combustion) of Bolivia and CO2 emissions (% of total fuel combustion) of Egypt, Arab Rep.?
Keep it short and to the point. 27.42. In the year 1988, what is the difference between the CO2 emissions (% of total fuel combustion) of Caribbean small states and CO2 emissions (% of total fuel combustion) of Middle East & North Africa (developing only)?
Provide a succinct answer. -9.62. In the year 1988, what is the difference between the CO2 emissions (% of total fuel combustion) of Caribbean small states and CO2 emissions (% of total fuel combustion) of Bolivia?
Ensure brevity in your answer.  -31.73. In the year 1988, what is the difference between the CO2 emissions (% of total fuel combustion) of Caribbean small states and CO2 emissions (% of total fuel combustion) of Egypt, Arab Rep.?
Offer a very short reply. -3.94. In the year 1988, what is the difference between the CO2 emissions (% of total fuel combustion) of Middle East & North Africa (developing only) and CO2 emissions (% of total fuel combustion) of Bolivia?
Provide a succinct answer. -22.11. In the year 1988, what is the difference between the CO2 emissions (% of total fuel combustion) in Middle East & North Africa (developing only) and CO2 emissions (% of total fuel combustion) in Egypt, Arab Rep.?
Your answer should be very brief. 5.69. In the year 1988, what is the difference between the CO2 emissions (% of total fuel combustion) of Bolivia and CO2 emissions (% of total fuel combustion) of Egypt, Arab Rep.?
Offer a terse response. 27.79. In the year 1989, what is the difference between the CO2 emissions (% of total fuel combustion) of Caribbean small states and CO2 emissions (% of total fuel combustion) of Middle East & North Africa (developing only)?
Your response must be concise. -11.31. In the year 1989, what is the difference between the CO2 emissions (% of total fuel combustion) in Caribbean small states and CO2 emissions (% of total fuel combustion) in Bolivia?
Provide a short and direct response. -31.4. In the year 1989, what is the difference between the CO2 emissions (% of total fuel combustion) of Caribbean small states and CO2 emissions (% of total fuel combustion) of Egypt, Arab Rep.?
Give a very brief answer. -5.87. In the year 1989, what is the difference between the CO2 emissions (% of total fuel combustion) of Middle East & North Africa (developing only) and CO2 emissions (% of total fuel combustion) of Bolivia?
Give a very brief answer. -20.09. In the year 1989, what is the difference between the CO2 emissions (% of total fuel combustion) of Middle East & North Africa (developing only) and CO2 emissions (% of total fuel combustion) of Egypt, Arab Rep.?
Give a very brief answer. 5.44. In the year 1989, what is the difference between the CO2 emissions (% of total fuel combustion) in Bolivia and CO2 emissions (% of total fuel combustion) in Egypt, Arab Rep.?
Ensure brevity in your answer.  25.53. In the year 1990, what is the difference between the CO2 emissions (% of total fuel combustion) in Caribbean small states and CO2 emissions (% of total fuel combustion) in Middle East & North Africa (developing only)?
Offer a very short reply. -12.31. In the year 1990, what is the difference between the CO2 emissions (% of total fuel combustion) in Caribbean small states and CO2 emissions (% of total fuel combustion) in Bolivia?
Provide a short and direct response. -29.78. In the year 1990, what is the difference between the CO2 emissions (% of total fuel combustion) in Caribbean small states and CO2 emissions (% of total fuel combustion) in Egypt, Arab Rep.?
Give a very brief answer. -7.16. In the year 1990, what is the difference between the CO2 emissions (% of total fuel combustion) in Middle East & North Africa (developing only) and CO2 emissions (% of total fuel combustion) in Bolivia?
Make the answer very short. -17.47. In the year 1990, what is the difference between the CO2 emissions (% of total fuel combustion) of Middle East & North Africa (developing only) and CO2 emissions (% of total fuel combustion) of Egypt, Arab Rep.?
Your response must be concise. 5.15. In the year 1990, what is the difference between the CO2 emissions (% of total fuel combustion) of Bolivia and CO2 emissions (% of total fuel combustion) of Egypt, Arab Rep.?
Make the answer very short. 22.62. In the year 1991, what is the difference between the CO2 emissions (% of total fuel combustion) of Caribbean small states and CO2 emissions (% of total fuel combustion) of Middle East & North Africa (developing only)?
Provide a short and direct response. -12.48. In the year 1991, what is the difference between the CO2 emissions (% of total fuel combustion) of Caribbean small states and CO2 emissions (% of total fuel combustion) of Bolivia?
Offer a very short reply. -31.95. In the year 1991, what is the difference between the CO2 emissions (% of total fuel combustion) of Caribbean small states and CO2 emissions (% of total fuel combustion) of Egypt, Arab Rep.?
Your response must be concise. -8.24. In the year 1991, what is the difference between the CO2 emissions (% of total fuel combustion) in Middle East & North Africa (developing only) and CO2 emissions (% of total fuel combustion) in Bolivia?
Give a very brief answer. -19.48. In the year 1991, what is the difference between the CO2 emissions (% of total fuel combustion) of Middle East & North Africa (developing only) and CO2 emissions (% of total fuel combustion) of Egypt, Arab Rep.?
Offer a terse response. 4.24. In the year 1991, what is the difference between the CO2 emissions (% of total fuel combustion) of Bolivia and CO2 emissions (% of total fuel combustion) of Egypt, Arab Rep.?
Ensure brevity in your answer.  23.72. What is the ratio of the CO2 emissions (% of total fuel combustion) in Caribbean small states in 1985 to that in 1986?
Your answer should be compact. 0.98. What is the ratio of the CO2 emissions (% of total fuel combustion) of Middle East & North Africa (developing only) in 1985 to that in 1986?
Offer a very short reply. 1.01. What is the ratio of the CO2 emissions (% of total fuel combustion) of Bolivia in 1985 to that in 1986?
Offer a terse response. 0.96. What is the ratio of the CO2 emissions (% of total fuel combustion) of Egypt, Arab Rep. in 1985 to that in 1986?
Your answer should be compact. 1.02. What is the ratio of the CO2 emissions (% of total fuel combustion) of Caribbean small states in 1985 to that in 1987?
Provide a succinct answer. 0.97. What is the ratio of the CO2 emissions (% of total fuel combustion) in Middle East & North Africa (developing only) in 1985 to that in 1987?
Ensure brevity in your answer.  1.02. What is the ratio of the CO2 emissions (% of total fuel combustion) in Bolivia in 1985 to that in 1987?
Make the answer very short. 0.89. What is the ratio of the CO2 emissions (% of total fuel combustion) in Egypt, Arab Rep. in 1985 to that in 1987?
Ensure brevity in your answer.  1.05. What is the ratio of the CO2 emissions (% of total fuel combustion) in Caribbean small states in 1985 to that in 1988?
Give a very brief answer. 1.18. What is the ratio of the CO2 emissions (% of total fuel combustion) of Middle East & North Africa (developing only) in 1985 to that in 1988?
Your answer should be very brief. 1.04. What is the ratio of the CO2 emissions (% of total fuel combustion) of Bolivia in 1985 to that in 1988?
Provide a succinct answer. 0.86. What is the ratio of the CO2 emissions (% of total fuel combustion) in Egypt, Arab Rep. in 1985 to that in 1988?
Your answer should be very brief. 0.99. What is the ratio of the CO2 emissions (% of total fuel combustion) in Caribbean small states in 1985 to that in 1989?
Your answer should be compact. 1.31. What is the ratio of the CO2 emissions (% of total fuel combustion) in Middle East & North Africa (developing only) in 1985 to that in 1989?
Your answer should be compact. 1.03. What is the ratio of the CO2 emissions (% of total fuel combustion) of Bolivia in 1985 to that in 1989?
Your response must be concise. 0.9. What is the ratio of the CO2 emissions (% of total fuel combustion) in Egypt, Arab Rep. in 1985 to that in 1989?
Give a very brief answer. 0.97. What is the ratio of the CO2 emissions (% of total fuel combustion) in Caribbean small states in 1985 to that in 1990?
Your response must be concise. 1.34. What is the ratio of the CO2 emissions (% of total fuel combustion) of Bolivia in 1985 to that in 1990?
Make the answer very short. 0.94. What is the ratio of the CO2 emissions (% of total fuel combustion) in Egypt, Arab Rep. in 1985 to that in 1990?
Offer a very short reply. 0.92. What is the ratio of the CO2 emissions (% of total fuel combustion) in Caribbean small states in 1985 to that in 1991?
Make the answer very short. 1.34. What is the ratio of the CO2 emissions (% of total fuel combustion) in Bolivia in 1985 to that in 1991?
Keep it short and to the point. 0.89. What is the ratio of the CO2 emissions (% of total fuel combustion) of Egypt, Arab Rep. in 1985 to that in 1991?
Keep it short and to the point. 0.87. What is the ratio of the CO2 emissions (% of total fuel combustion) of Caribbean small states in 1986 to that in 1987?
Your answer should be very brief. 1. What is the ratio of the CO2 emissions (% of total fuel combustion) of Middle East & North Africa (developing only) in 1986 to that in 1987?
Keep it short and to the point. 1.01. What is the ratio of the CO2 emissions (% of total fuel combustion) of Bolivia in 1986 to that in 1987?
Offer a terse response. 0.92. What is the ratio of the CO2 emissions (% of total fuel combustion) of Egypt, Arab Rep. in 1986 to that in 1987?
Keep it short and to the point. 1.02. What is the ratio of the CO2 emissions (% of total fuel combustion) in Caribbean small states in 1986 to that in 1988?
Provide a succinct answer. 1.2. What is the ratio of the CO2 emissions (% of total fuel combustion) in Middle East & North Africa (developing only) in 1986 to that in 1988?
Make the answer very short. 1.02. What is the ratio of the CO2 emissions (% of total fuel combustion) of Bolivia in 1986 to that in 1988?
Keep it short and to the point. 0.89. What is the ratio of the CO2 emissions (% of total fuel combustion) in Egypt, Arab Rep. in 1986 to that in 1988?
Provide a short and direct response. 0.97. What is the ratio of the CO2 emissions (% of total fuel combustion) in Caribbean small states in 1986 to that in 1989?
Your answer should be very brief. 1.34. What is the ratio of the CO2 emissions (% of total fuel combustion) in Middle East & North Africa (developing only) in 1986 to that in 1989?
Your response must be concise. 1.02. What is the ratio of the CO2 emissions (% of total fuel combustion) in Bolivia in 1986 to that in 1989?
Your answer should be compact. 0.93. What is the ratio of the CO2 emissions (% of total fuel combustion) in Caribbean small states in 1986 to that in 1990?
Your answer should be very brief. 1.37. What is the ratio of the CO2 emissions (% of total fuel combustion) of Middle East & North Africa (developing only) in 1986 to that in 1990?
Keep it short and to the point. 0.99. What is the ratio of the CO2 emissions (% of total fuel combustion) of Bolivia in 1986 to that in 1990?
Your answer should be very brief. 0.97. What is the ratio of the CO2 emissions (% of total fuel combustion) in Egypt, Arab Rep. in 1986 to that in 1990?
Ensure brevity in your answer.  0.9. What is the ratio of the CO2 emissions (% of total fuel combustion) of Caribbean small states in 1986 to that in 1991?
Keep it short and to the point. 1.37. What is the ratio of the CO2 emissions (% of total fuel combustion) in Middle East & North Africa (developing only) in 1986 to that in 1991?
Your answer should be very brief. 0.98. What is the ratio of the CO2 emissions (% of total fuel combustion) of Bolivia in 1986 to that in 1991?
Give a very brief answer. 0.93. What is the ratio of the CO2 emissions (% of total fuel combustion) in Egypt, Arab Rep. in 1986 to that in 1991?
Provide a succinct answer. 0.85. What is the ratio of the CO2 emissions (% of total fuel combustion) of Caribbean small states in 1987 to that in 1988?
Provide a succinct answer. 1.21. What is the ratio of the CO2 emissions (% of total fuel combustion) in Middle East & North Africa (developing only) in 1987 to that in 1988?
Provide a short and direct response. 1.02. What is the ratio of the CO2 emissions (% of total fuel combustion) of Bolivia in 1987 to that in 1988?
Your answer should be very brief. 0.97. What is the ratio of the CO2 emissions (% of total fuel combustion) in Egypt, Arab Rep. in 1987 to that in 1988?
Ensure brevity in your answer.  0.94. What is the ratio of the CO2 emissions (% of total fuel combustion) in Caribbean small states in 1987 to that in 1989?
Your answer should be very brief. 1.35. What is the ratio of the CO2 emissions (% of total fuel combustion) of Middle East & North Africa (developing only) in 1987 to that in 1989?
Keep it short and to the point. 1.01. What is the ratio of the CO2 emissions (% of total fuel combustion) in Bolivia in 1987 to that in 1989?
Offer a terse response. 1.01. What is the ratio of the CO2 emissions (% of total fuel combustion) of Egypt, Arab Rep. in 1987 to that in 1989?
Offer a terse response. 0.92. What is the ratio of the CO2 emissions (% of total fuel combustion) in Caribbean small states in 1987 to that in 1990?
Give a very brief answer. 1.38. What is the ratio of the CO2 emissions (% of total fuel combustion) in Middle East & North Africa (developing only) in 1987 to that in 1990?
Provide a short and direct response. 0.98. What is the ratio of the CO2 emissions (% of total fuel combustion) of Bolivia in 1987 to that in 1990?
Your answer should be compact. 1.05. What is the ratio of the CO2 emissions (% of total fuel combustion) of Egypt, Arab Rep. in 1987 to that in 1990?
Give a very brief answer. 0.88. What is the ratio of the CO2 emissions (% of total fuel combustion) of Caribbean small states in 1987 to that in 1991?
Offer a very short reply. 1.38. What is the ratio of the CO2 emissions (% of total fuel combustion) in Middle East & North Africa (developing only) in 1987 to that in 1991?
Keep it short and to the point. 0.98. What is the ratio of the CO2 emissions (% of total fuel combustion) in Egypt, Arab Rep. in 1987 to that in 1991?
Offer a terse response. 0.83. What is the ratio of the CO2 emissions (% of total fuel combustion) of Caribbean small states in 1988 to that in 1989?
Offer a very short reply. 1.12. What is the ratio of the CO2 emissions (% of total fuel combustion) in Bolivia in 1988 to that in 1989?
Your answer should be very brief. 1.04. What is the ratio of the CO2 emissions (% of total fuel combustion) of Egypt, Arab Rep. in 1988 to that in 1989?
Give a very brief answer. 0.98. What is the ratio of the CO2 emissions (% of total fuel combustion) in Caribbean small states in 1988 to that in 1990?
Give a very brief answer. 1.14. What is the ratio of the CO2 emissions (% of total fuel combustion) of Middle East & North Africa (developing only) in 1988 to that in 1990?
Your answer should be very brief. 0.97. What is the ratio of the CO2 emissions (% of total fuel combustion) of Bolivia in 1988 to that in 1990?
Provide a short and direct response. 1.09. What is the ratio of the CO2 emissions (% of total fuel combustion) of Egypt, Arab Rep. in 1988 to that in 1990?
Your answer should be compact. 0.93. What is the ratio of the CO2 emissions (% of total fuel combustion) of Caribbean small states in 1988 to that in 1991?
Offer a very short reply. 1.14. What is the ratio of the CO2 emissions (% of total fuel combustion) of Middle East & North Africa (developing only) in 1988 to that in 1991?
Your answer should be compact. 0.96. What is the ratio of the CO2 emissions (% of total fuel combustion) in Bolivia in 1988 to that in 1991?
Give a very brief answer. 1.04. What is the ratio of the CO2 emissions (% of total fuel combustion) in Egypt, Arab Rep. in 1988 to that in 1991?
Make the answer very short. 0.88. What is the ratio of the CO2 emissions (% of total fuel combustion) of Middle East & North Africa (developing only) in 1989 to that in 1990?
Your answer should be compact. 0.97. What is the ratio of the CO2 emissions (% of total fuel combustion) in Bolivia in 1989 to that in 1990?
Offer a terse response. 1.04. What is the ratio of the CO2 emissions (% of total fuel combustion) in Egypt, Arab Rep. in 1989 to that in 1990?
Ensure brevity in your answer.  0.95. What is the ratio of the CO2 emissions (% of total fuel combustion) in Caribbean small states in 1989 to that in 1991?
Offer a very short reply. 1.02. What is the ratio of the CO2 emissions (% of total fuel combustion) in Middle East & North Africa (developing only) in 1989 to that in 1991?
Your answer should be very brief. 0.97. What is the ratio of the CO2 emissions (% of total fuel combustion) of Bolivia in 1989 to that in 1991?
Your answer should be very brief. 0.99. What is the ratio of the CO2 emissions (% of total fuel combustion) in Egypt, Arab Rep. in 1989 to that in 1991?
Your response must be concise. 0.9. What is the ratio of the CO2 emissions (% of total fuel combustion) of Caribbean small states in 1990 to that in 1991?
Offer a terse response. 1. What is the ratio of the CO2 emissions (% of total fuel combustion) in Bolivia in 1990 to that in 1991?
Provide a short and direct response. 0.95. What is the difference between the highest and the second highest CO2 emissions (% of total fuel combustion) of Caribbean small states?
Offer a terse response. 0.06. What is the difference between the highest and the second highest CO2 emissions (% of total fuel combustion) in Middle East & North Africa (developing only)?
Make the answer very short. 0.15. What is the difference between the highest and the second highest CO2 emissions (% of total fuel combustion) in Bolivia?
Your answer should be very brief. 1.42. What is the difference between the highest and the second highest CO2 emissions (% of total fuel combustion) in Egypt, Arab Rep.?
Offer a very short reply. 1.06. What is the difference between the highest and the lowest CO2 emissions (% of total fuel combustion) of Caribbean small states?
Give a very brief answer. 4.9. What is the difference between the highest and the lowest CO2 emissions (% of total fuel combustion) in Bolivia?
Your answer should be very brief. 6.39. What is the difference between the highest and the lowest CO2 emissions (% of total fuel combustion) of Egypt, Arab Rep.?
Your answer should be very brief. 3.52. 